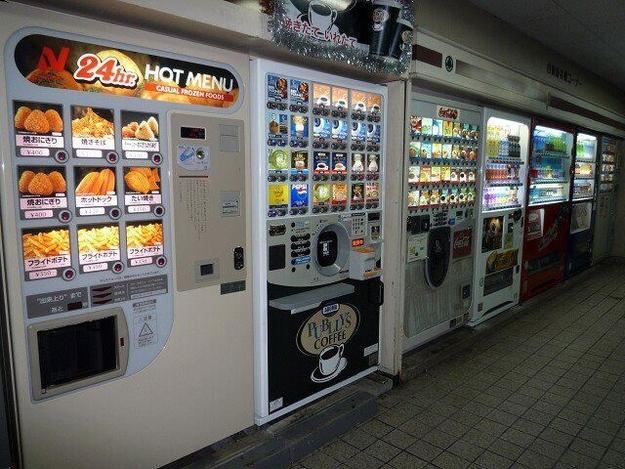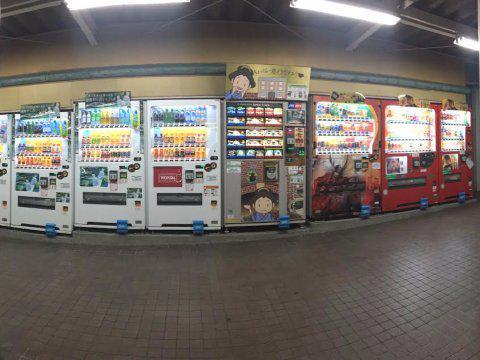The first image is the image on the left, the second image is the image on the right. Analyze the images presented: Is the assertion "There are no more than three vending machines in the image on the right." valid? Answer yes or no. No. The first image is the image on the left, the second image is the image on the right. Assess this claim about the two images: "Each image shows a row of at least three vending machines.". Correct or not? Answer yes or no. Yes. The first image is the image on the left, the second image is the image on the right. Considering the images on both sides, is "One of the machines sitting amongst the others is blue." valid? Answer yes or no. No. The first image is the image on the left, the second image is the image on the right. Analyze the images presented: Is the assertion "An image focuses on a blue vending machine that dispenses some bottled items." valid? Answer yes or no. No. 